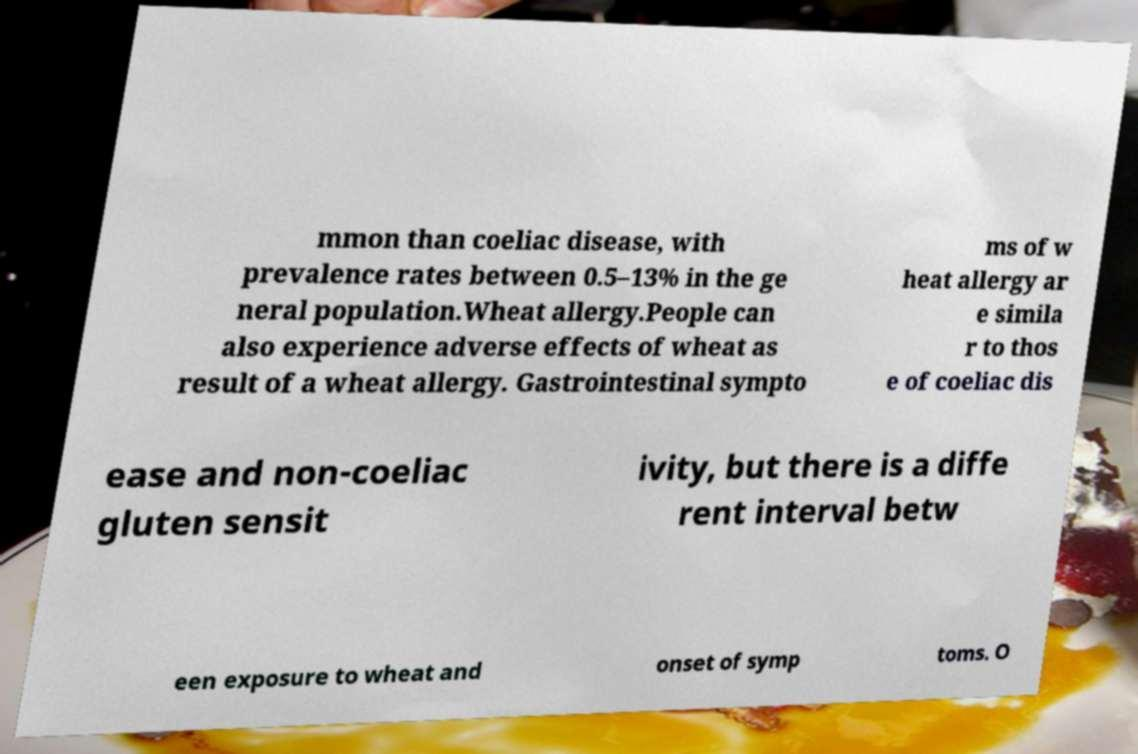Please read and relay the text visible in this image. What does it say? mmon than coeliac disease, with prevalence rates between 0.5–13% in the ge neral population.Wheat allergy.People can also experience adverse effects of wheat as result of a wheat allergy. Gastrointestinal sympto ms of w heat allergy ar e simila r to thos e of coeliac dis ease and non-coeliac gluten sensit ivity, but there is a diffe rent interval betw een exposure to wheat and onset of symp toms. O 